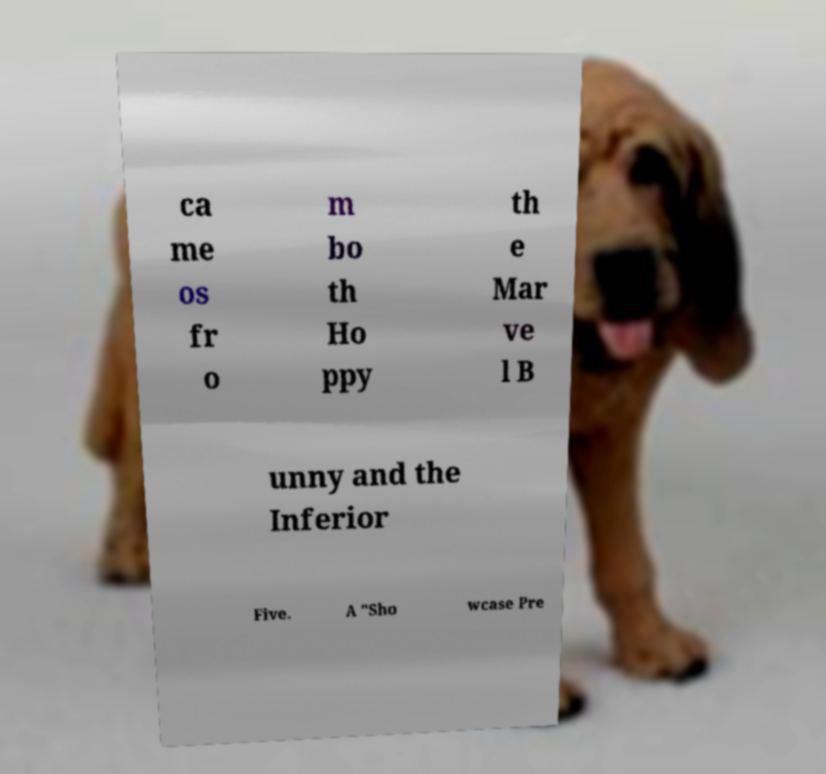Could you assist in decoding the text presented in this image and type it out clearly? ca me os fr o m bo th Ho ppy th e Mar ve l B unny and the Inferior Five. A "Sho wcase Pre 